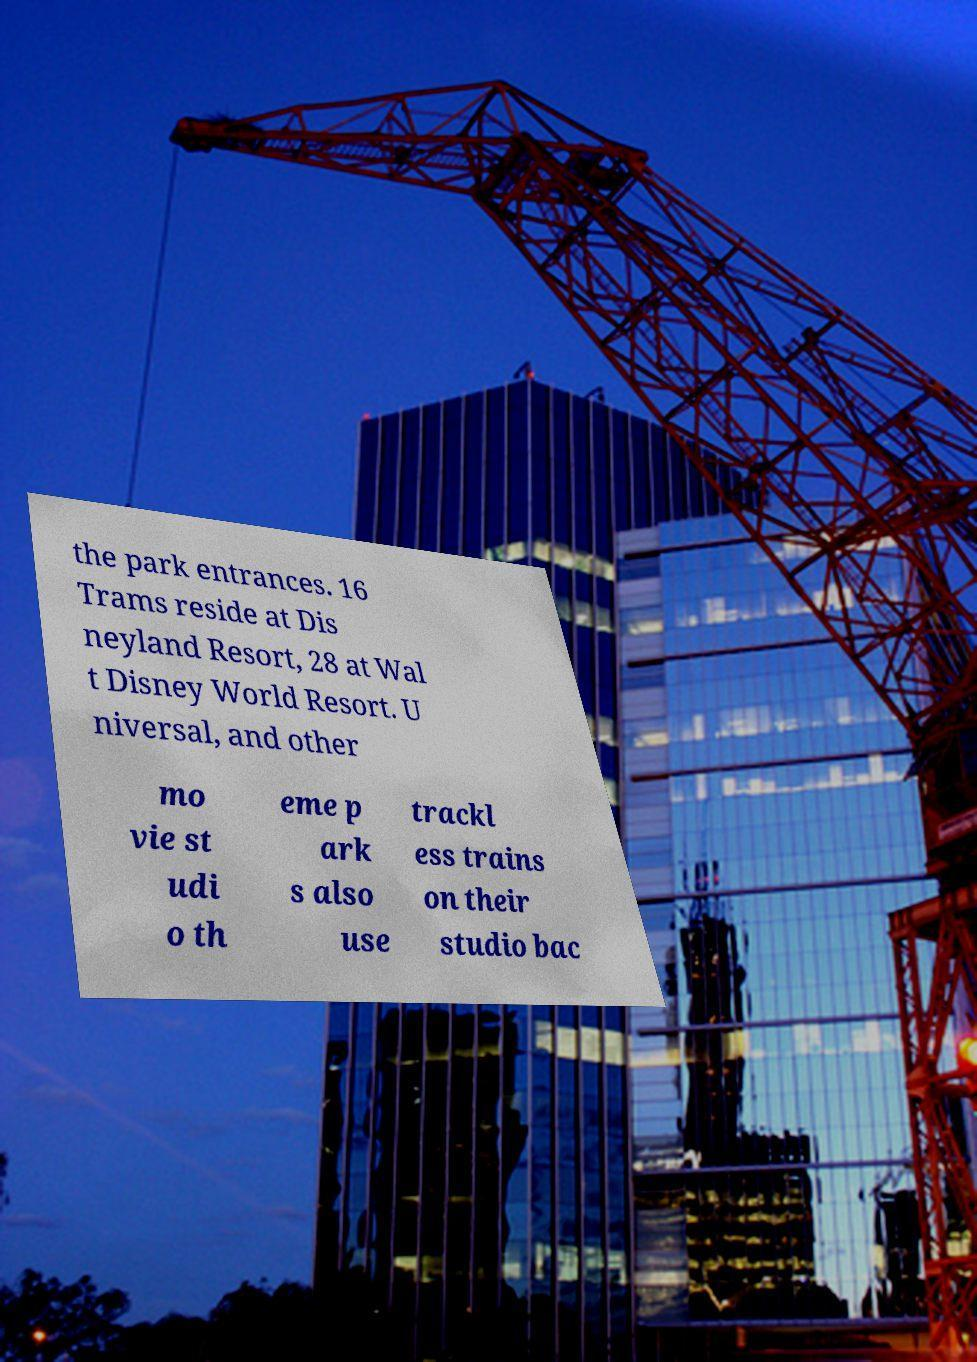Can you read and provide the text displayed in the image?This photo seems to have some interesting text. Can you extract and type it out for me? the park entrances. 16 Trams reside at Dis neyland Resort, 28 at Wal t Disney World Resort. U niversal, and other mo vie st udi o th eme p ark s also use trackl ess trains on their studio bac 